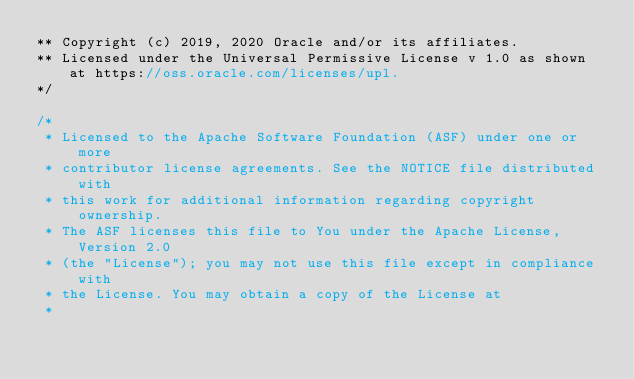Convert code to text. <code><loc_0><loc_0><loc_500><loc_500><_Java_>** Copyright (c) 2019, 2020 Oracle and/or its affiliates.
** Licensed under the Universal Permissive License v 1.0 as shown at https://oss.oracle.com/licenses/upl.
*/

/*
 * Licensed to the Apache Software Foundation (ASF) under one or more
 * contributor license agreements. See the NOTICE file distributed with
 * this work for additional information regarding copyright ownership.
 * The ASF licenses this file to You under the Apache License, Version 2.0
 * (the "License"); you may not use this file except in compliance with
 * the License. You may obtain a copy of the License at
 *</code> 